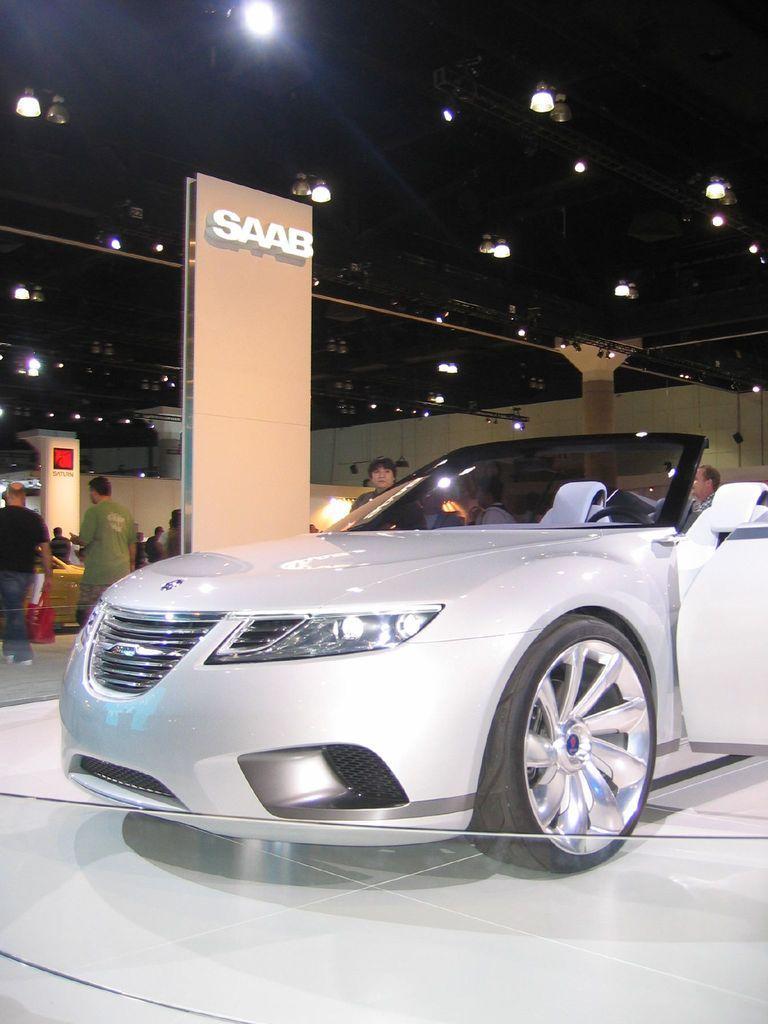Describe this image in one or two sentences. In this picture we can see the car in the showroom. Behind there are some persons standing and watching them. On the top ceiling we can see the lights. 